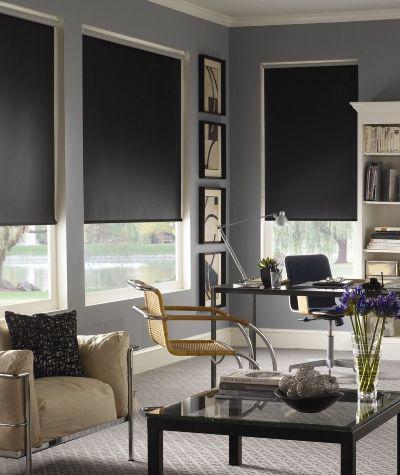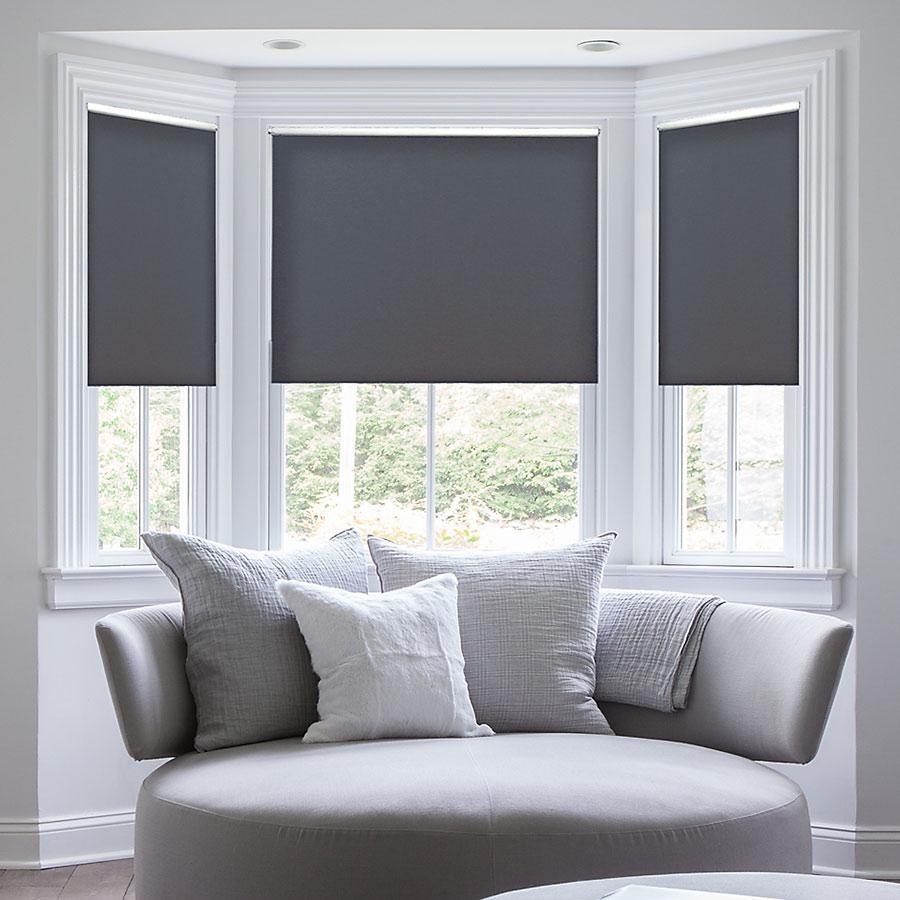The first image is the image on the left, the second image is the image on the right. Assess this claim about the two images: "In at least one image there are three blinds  behind a sofa chair.". Correct or not? Answer yes or no. Yes. The first image is the image on the left, the second image is the image on the right. Evaluate the accuracy of this statement regarding the images: "All of the blinds in each image are open at equal lengths to the others in the same image.". Is it true? Answer yes or no. Yes. 